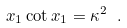Convert formula to latex. <formula><loc_0><loc_0><loc_500><loc_500>x _ { 1 } \cot x _ { 1 } = \kappa ^ { 2 } \ .</formula> 